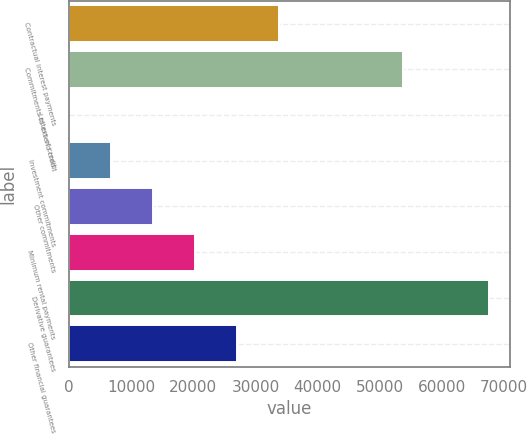<chart> <loc_0><loc_0><loc_500><loc_500><bar_chart><fcel>Contractual interest payments<fcel>Commitments to extend credit<fcel>Letters of credit<fcel>Investment commitments<fcel>Other commitments<fcel>Minimum rental payments<fcel>Derivative guarantees<fcel>Other financial guarantees<nl><fcel>33823<fcel>53822<fcel>3<fcel>6767<fcel>13531<fcel>20295<fcel>67643<fcel>27059<nl></chart> 